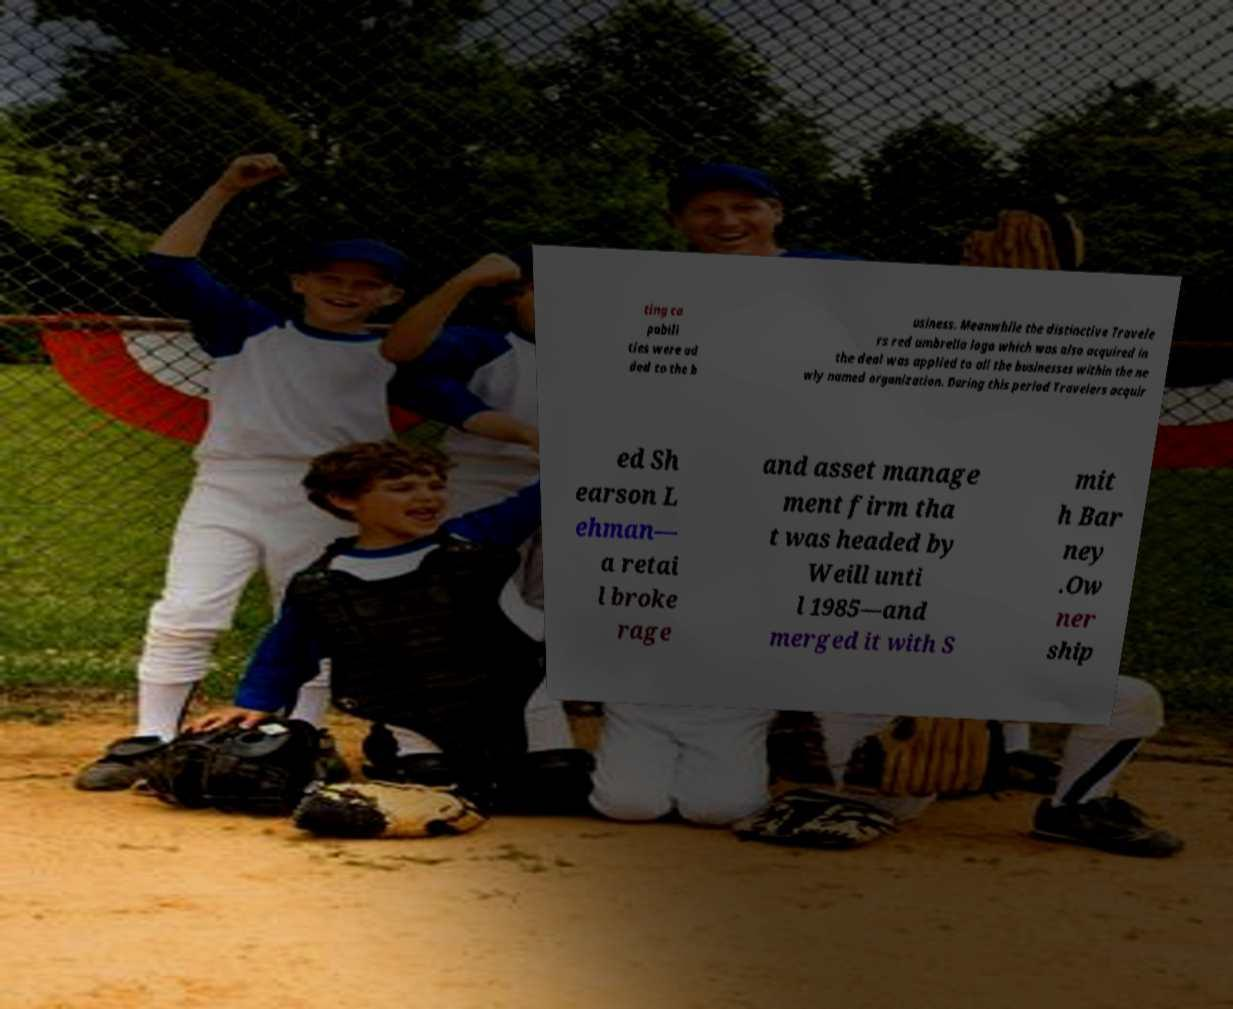Can you accurately transcribe the text from the provided image for me? ting ca pabili ties were ad ded to the b usiness. Meanwhile the distinctive Travele rs red umbrella logo which was also acquired in the deal was applied to all the businesses within the ne wly named organization. During this period Travelers acquir ed Sh earson L ehman— a retai l broke rage and asset manage ment firm tha t was headed by Weill unti l 1985—and merged it with S mit h Bar ney .Ow ner ship 